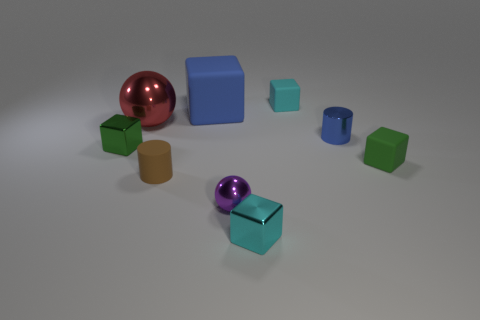Subtract all green balls. How many green cubes are left? 2 Subtract all small green blocks. How many blocks are left? 3 Add 1 cyan matte cubes. How many objects exist? 10 Subtract 1 blocks. How many blocks are left? 4 Subtract all blue blocks. How many blocks are left? 4 Subtract all balls. How many objects are left? 7 Add 6 rubber cubes. How many rubber cubes are left? 9 Add 5 yellow rubber spheres. How many yellow rubber spheres exist? 5 Subtract 0 gray spheres. How many objects are left? 9 Subtract all purple balls. Subtract all cyan cylinders. How many balls are left? 1 